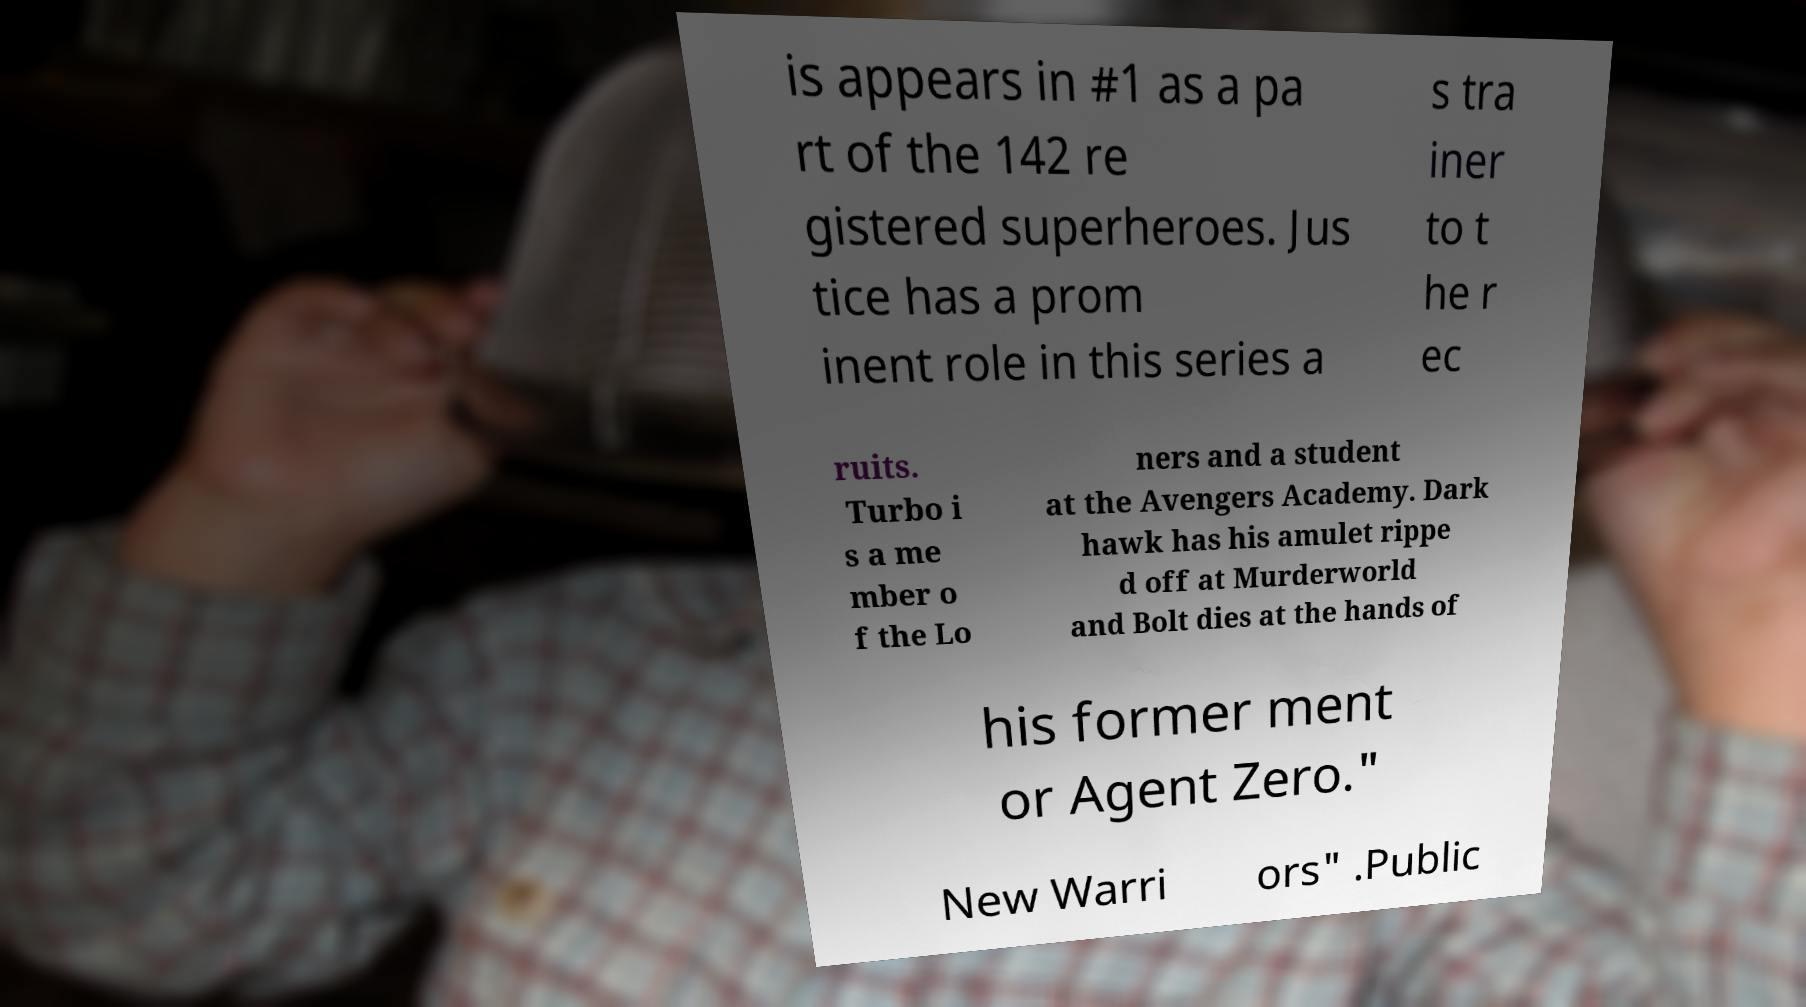Could you assist in decoding the text presented in this image and type it out clearly? is appears in #1 as a pa rt of the 142 re gistered superheroes. Jus tice has a prom inent role in this series a s tra iner to t he r ec ruits. Turbo i s a me mber o f the Lo ners and a student at the Avengers Academy. Dark hawk has his amulet rippe d off at Murderworld and Bolt dies at the hands of his former ment or Agent Zero." New Warri ors" .Public 